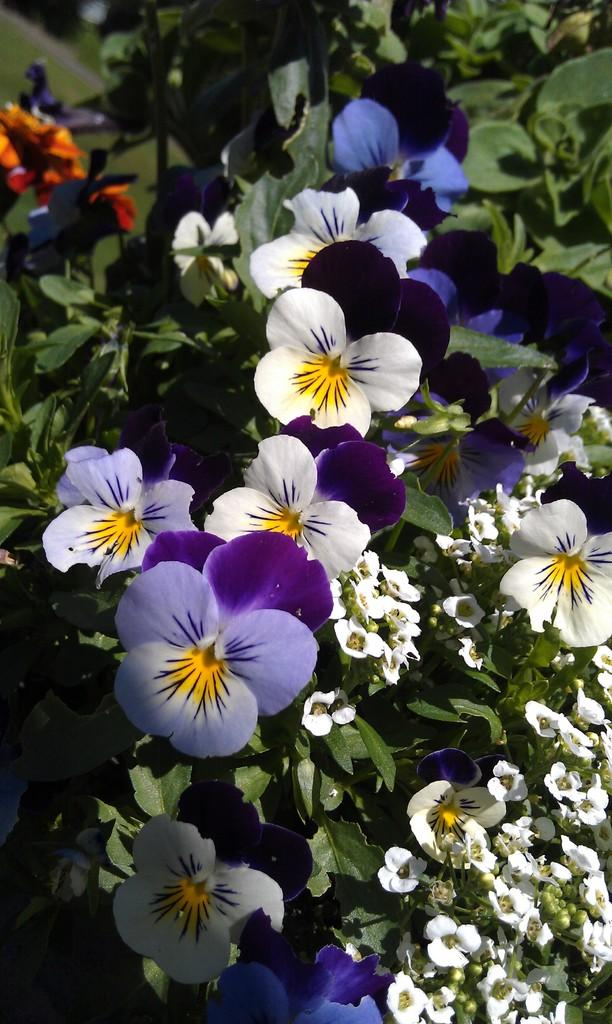What type of plants are featured in the image? There are pansy flower plants in the image. What type of drug is being administered to the pansy flower plants in the image? There is no drug being administered to the pansy flower plants in the image, as the provided fact does not mention any drug or treatment. 